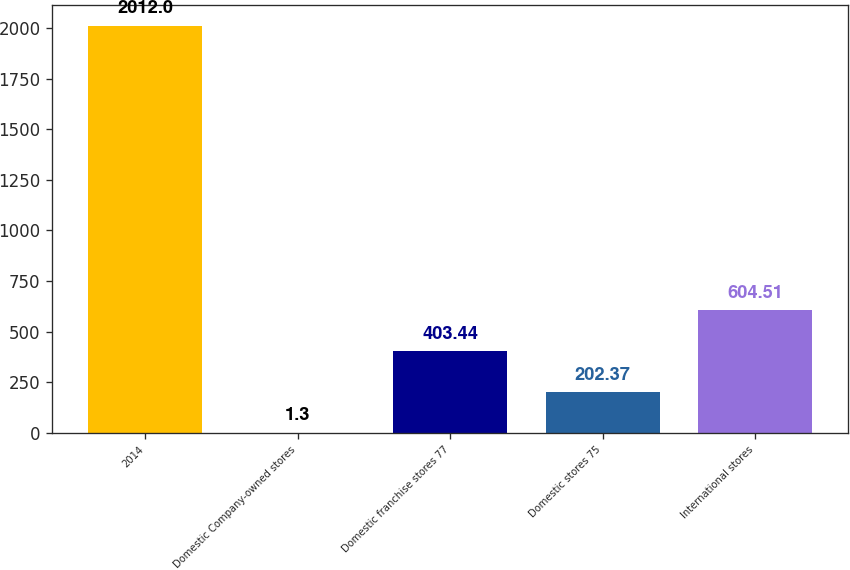<chart> <loc_0><loc_0><loc_500><loc_500><bar_chart><fcel>2014<fcel>Domestic Company-owned stores<fcel>Domestic franchise stores 77<fcel>Domestic stores 75<fcel>International stores<nl><fcel>2012<fcel>1.3<fcel>403.44<fcel>202.37<fcel>604.51<nl></chart> 